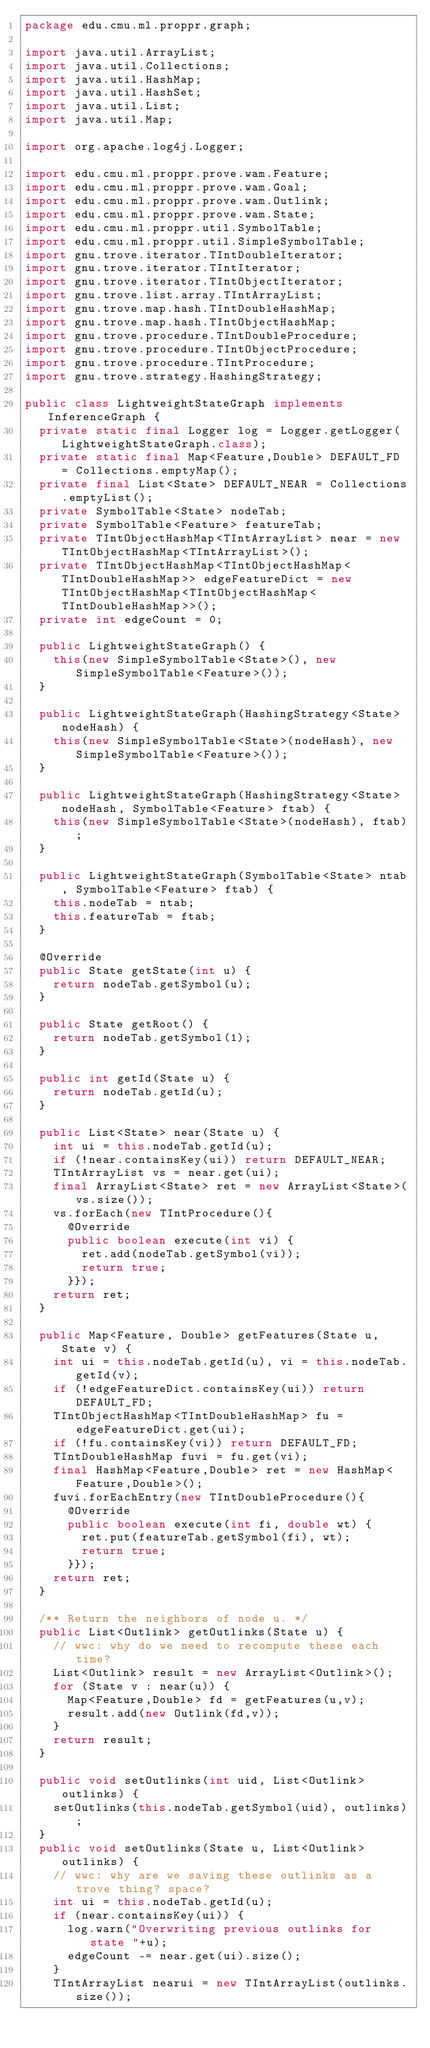<code> <loc_0><loc_0><loc_500><loc_500><_Java_>package edu.cmu.ml.proppr.graph;

import java.util.ArrayList;
import java.util.Collections;
import java.util.HashMap;
import java.util.HashSet;
import java.util.List;
import java.util.Map;

import org.apache.log4j.Logger;

import edu.cmu.ml.proppr.prove.wam.Feature;
import edu.cmu.ml.proppr.prove.wam.Goal;
import edu.cmu.ml.proppr.prove.wam.Outlink;
import edu.cmu.ml.proppr.prove.wam.State;
import edu.cmu.ml.proppr.util.SymbolTable;
import edu.cmu.ml.proppr.util.SimpleSymbolTable;
import gnu.trove.iterator.TIntDoubleIterator;
import gnu.trove.iterator.TIntIterator;
import gnu.trove.iterator.TIntObjectIterator;
import gnu.trove.list.array.TIntArrayList;
import gnu.trove.map.hash.TIntDoubleHashMap;
import gnu.trove.map.hash.TIntObjectHashMap;
import gnu.trove.procedure.TIntDoubleProcedure;
import gnu.trove.procedure.TIntObjectProcedure;
import gnu.trove.procedure.TIntProcedure;
import gnu.trove.strategy.HashingStrategy;

public class LightweightStateGraph implements InferenceGraph {
	private static final Logger log = Logger.getLogger(LightweightStateGraph.class);
	private static final Map<Feature,Double> DEFAULT_FD = Collections.emptyMap();
	private final List<State> DEFAULT_NEAR = Collections.emptyList();
	private SymbolTable<State> nodeTab;
	private SymbolTable<Feature> featureTab;
	private TIntObjectHashMap<TIntArrayList> near = new TIntObjectHashMap<TIntArrayList>();
	private TIntObjectHashMap<TIntObjectHashMap<TIntDoubleHashMap>> edgeFeatureDict = new TIntObjectHashMap<TIntObjectHashMap<TIntDoubleHashMap>>();
	private int edgeCount = 0;

	public LightweightStateGraph() {
		this(new SimpleSymbolTable<State>(), new SimpleSymbolTable<Feature>());
	}

	public LightweightStateGraph(HashingStrategy<State> nodeHash) {
		this(new SimpleSymbolTable<State>(nodeHash), new SimpleSymbolTable<Feature>());
	}
	
	public LightweightStateGraph(HashingStrategy<State> nodeHash, SymbolTable<Feature> ftab) {
		this(new SimpleSymbolTable<State>(nodeHash), ftab);
	}
	
	public LightweightStateGraph(SymbolTable<State> ntab, SymbolTable<Feature> ftab) {
		this.nodeTab = ntab;
		this.featureTab = ftab;
	}

	@Override
	public State getState(int u) {
		return nodeTab.getSymbol(u);
	}

	public State getRoot() {
		return nodeTab.getSymbol(1);
	}

	public int getId(State u) {
		return nodeTab.getId(u);
	}

	public List<State> near(State u) {
		int ui = this.nodeTab.getId(u);
		if (!near.containsKey(ui)) return DEFAULT_NEAR;
		TIntArrayList vs = near.get(ui);
		final ArrayList<State> ret = new ArrayList<State>(vs.size());
		vs.forEach(new TIntProcedure(){
			@Override
			public boolean execute(int vi) {
				ret.add(nodeTab.getSymbol(vi));
				return true;
			}});
		return ret;
	}

	public Map<Feature, Double> getFeatures(State u, State v) {
		int ui = this.nodeTab.getId(u), vi = this.nodeTab.getId(v);
		if (!edgeFeatureDict.containsKey(ui)) return DEFAULT_FD;
		TIntObjectHashMap<TIntDoubleHashMap> fu = edgeFeatureDict.get(ui);
		if (!fu.containsKey(vi)) return DEFAULT_FD;
		TIntDoubleHashMap fuvi = fu.get(vi); 
		final HashMap<Feature,Double> ret = new HashMap<Feature,Double>();
		fuvi.forEachEntry(new TIntDoubleProcedure(){
			@Override
			public boolean execute(int fi, double wt) {
				ret.put(featureTab.getSymbol(fi), wt);
				return true;
			}});
		return ret;
	}

	/** Return the neighbors of node u. */
	public List<Outlink> getOutlinks(State u) {
		// wwc: why do we need to recompute these each time?
		List<Outlink> result = new ArrayList<Outlink>();
		for (State v : near(u)) {
			Map<Feature,Double> fd = getFeatures(u,v);
			result.add(new Outlink(fd,v));
		}
		return result;
	}
	
	public void setOutlinks(int uid, List<Outlink> outlinks) {
		setOutlinks(this.nodeTab.getSymbol(uid), outlinks);
	}
	public void setOutlinks(State u, List<Outlink> outlinks) {
		// wwc: why are we saving these outlinks as a trove thing? space?
		int ui = this.nodeTab.getId(u);
		if (near.containsKey(ui)) {
			log.warn("Overwriting previous outlinks for state "+u);
			edgeCount -= near.get(ui).size();
		}
		TIntArrayList nearui = new TIntArrayList(outlinks.size());</code> 